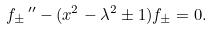Convert formula to latex. <formula><loc_0><loc_0><loc_500><loc_500>f _ { \pm } \, ^ { \prime \prime } - ( x ^ { 2 } - \lambda ^ { 2 } \pm 1 ) f _ { \pm } = 0 .</formula> 